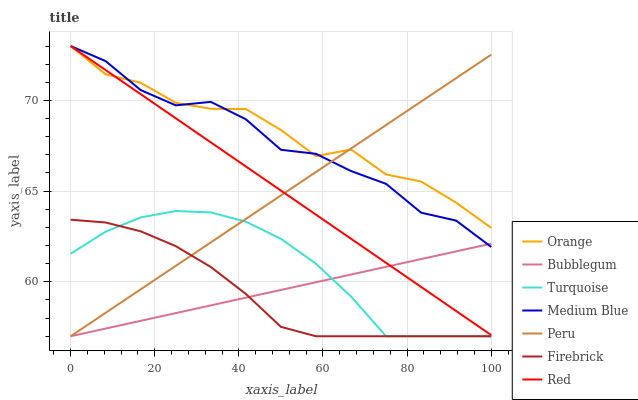Does Firebrick have the minimum area under the curve?
Answer yes or no. Yes. Does Orange have the maximum area under the curve?
Answer yes or no. Yes. Does Medium Blue have the minimum area under the curve?
Answer yes or no. No. Does Medium Blue have the maximum area under the curve?
Answer yes or no. No. Is Bubblegum the smoothest?
Answer yes or no. Yes. Is Medium Blue the roughest?
Answer yes or no. Yes. Is Firebrick the smoothest?
Answer yes or no. No. Is Firebrick the roughest?
Answer yes or no. No. Does Medium Blue have the lowest value?
Answer yes or no. No. Does Red have the highest value?
Answer yes or no. Yes. Does Firebrick have the highest value?
Answer yes or no. No. Is Firebrick less than Red?
Answer yes or no. Yes. Is Medium Blue greater than Firebrick?
Answer yes or no. Yes. Does Orange intersect Peru?
Answer yes or no. Yes. Is Orange less than Peru?
Answer yes or no. No. Is Orange greater than Peru?
Answer yes or no. No. Does Firebrick intersect Red?
Answer yes or no. No. 